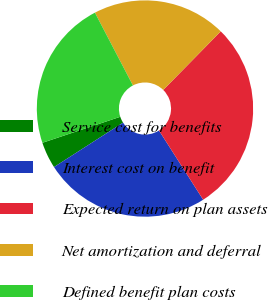Convert chart. <chart><loc_0><loc_0><loc_500><loc_500><pie_chart><fcel>Service cost for benefits<fcel>Interest cost on benefit<fcel>Expected return on plan assets<fcel>Net amortization and deferral<fcel>Defined benefit plan costs<nl><fcel>3.97%<fcel>24.94%<fcel>28.61%<fcel>20.01%<fcel>22.47%<nl></chart> 